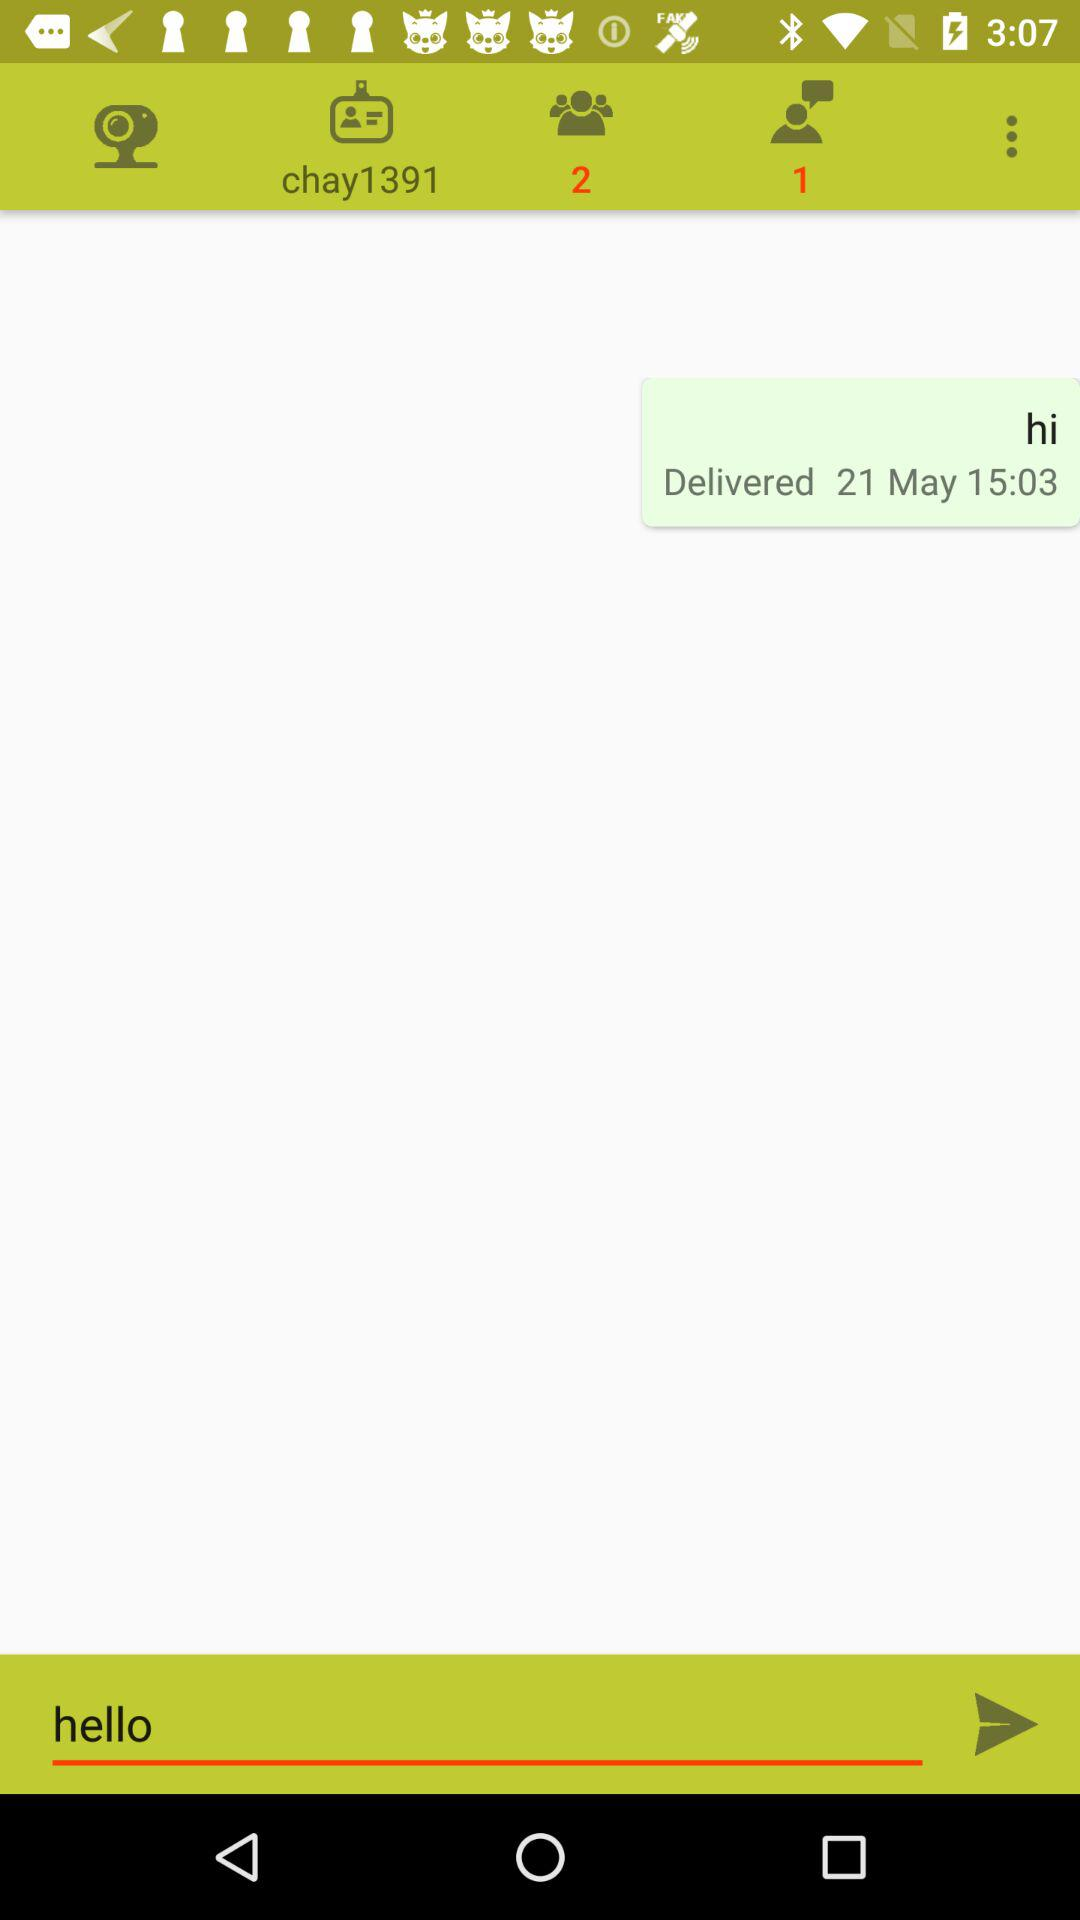What is the profile name? The profile name is "chay1391". 